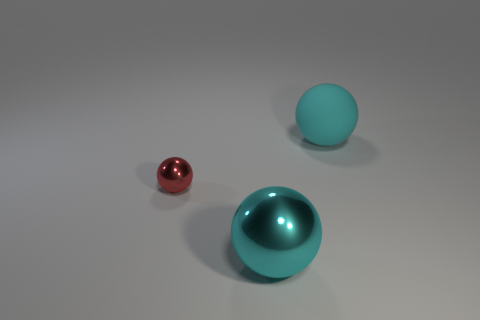Is there any other thing that has the same size as the red metallic object?
Offer a very short reply. No. There is another red thing that is the same shape as the large rubber object; what size is it?
Offer a very short reply. Small. Are there fewer large objects to the left of the tiny shiny sphere than purple metal spheres?
Offer a very short reply. No. How big is the metallic ball that is in front of the tiny object?
Your response must be concise. Large. The big metal object that is the same shape as the small metal object is what color?
Your response must be concise. Cyan. How many metal balls are the same color as the big matte ball?
Ensure brevity in your answer.  1. Is there anything else that has the same shape as the large cyan metal object?
Your response must be concise. Yes. There is a cyan ball on the right side of the cyan object that is in front of the red shiny thing; is there a metallic thing to the right of it?
Provide a short and direct response. No. What number of other tiny red spheres have the same material as the small red sphere?
Keep it short and to the point. 0. Do the metal ball that is to the right of the small red metal sphere and the ball that is behind the small object have the same size?
Offer a very short reply. Yes. 